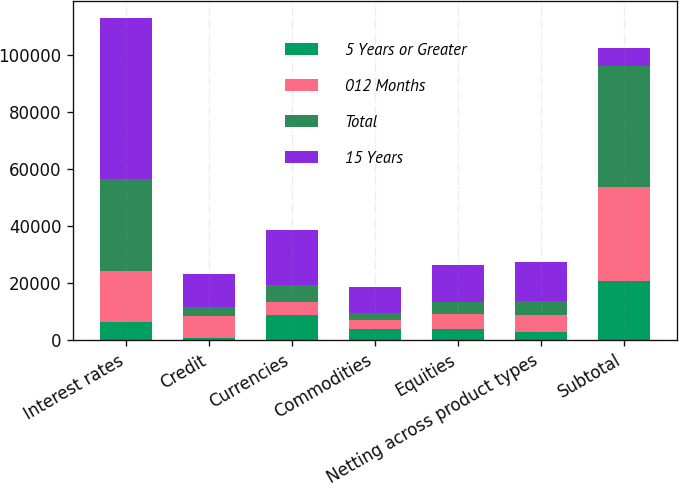<chart> <loc_0><loc_0><loc_500><loc_500><stacked_bar_chart><ecel><fcel>Interest rates<fcel>Credit<fcel>Currencies<fcel>Commodities<fcel>Equities<fcel>Netting across product types<fcel>Subtotal<nl><fcel>5 Years or Greater<fcel>6266<fcel>809<fcel>8586<fcel>3970<fcel>3775<fcel>2811<fcel>20595<nl><fcel>012 Months<fcel>17860<fcel>7537<fcel>4849<fcel>3119<fcel>5476<fcel>5831<fcel>33010<nl><fcel>Total<fcel>32422<fcel>3168<fcel>5782<fcel>2267<fcel>3937<fcel>5082<fcel>42494<nl><fcel>15 Years<fcel>56548<fcel>11514<fcel>19217<fcel>9356<fcel>13188<fcel>13724<fcel>6266<nl></chart> 